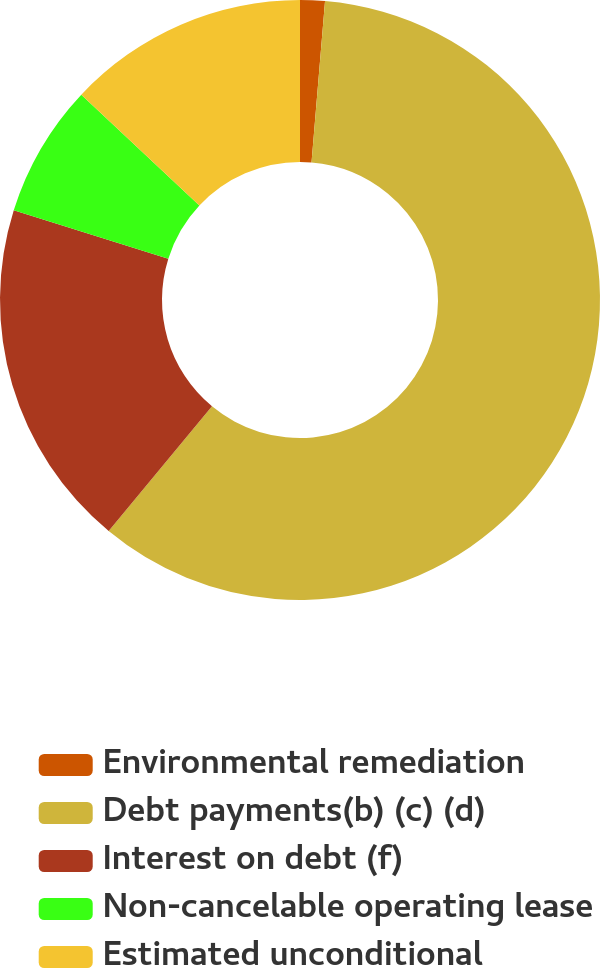Convert chart. <chart><loc_0><loc_0><loc_500><loc_500><pie_chart><fcel>Environmental remediation<fcel>Debt payments(b) (c) (d)<fcel>Interest on debt (f)<fcel>Non-cancelable operating lease<fcel>Estimated unconditional<nl><fcel>1.33%<fcel>59.67%<fcel>18.83%<fcel>7.16%<fcel>13.0%<nl></chart> 